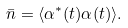Convert formula to latex. <formula><loc_0><loc_0><loc_500><loc_500>\bar { n } = \langle \alpha ^ { * } ( t ) \alpha ( t ) \rangle .</formula> 